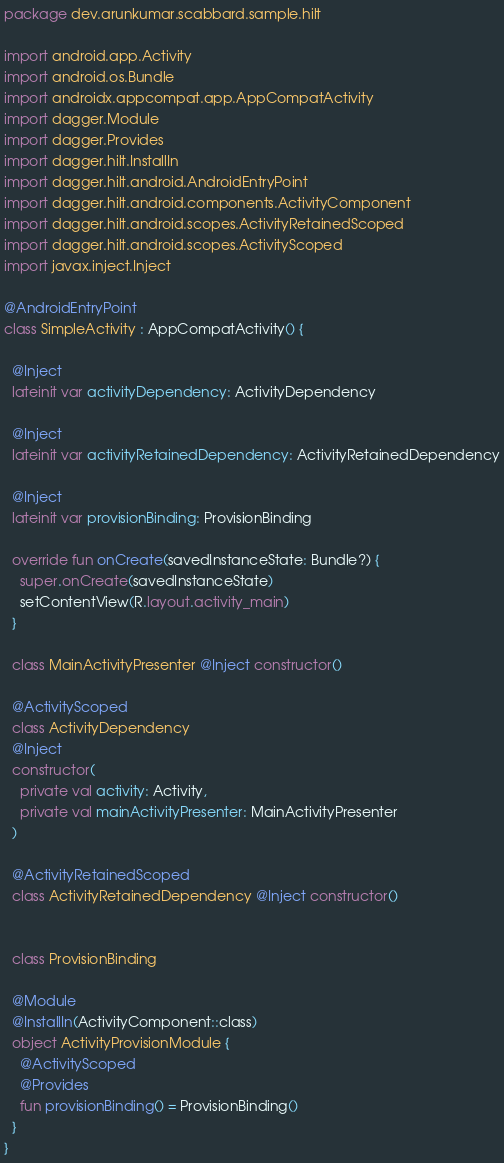Convert code to text. <code><loc_0><loc_0><loc_500><loc_500><_Kotlin_>package dev.arunkumar.scabbard.sample.hilt

import android.app.Activity
import android.os.Bundle
import androidx.appcompat.app.AppCompatActivity
import dagger.Module
import dagger.Provides
import dagger.hilt.InstallIn
import dagger.hilt.android.AndroidEntryPoint
import dagger.hilt.android.components.ActivityComponent
import dagger.hilt.android.scopes.ActivityRetainedScoped
import dagger.hilt.android.scopes.ActivityScoped
import javax.inject.Inject

@AndroidEntryPoint
class SimpleActivity : AppCompatActivity() {

  @Inject
  lateinit var activityDependency: ActivityDependency

  @Inject
  lateinit var activityRetainedDependency: ActivityRetainedDependency

  @Inject
  lateinit var provisionBinding: ProvisionBinding

  override fun onCreate(savedInstanceState: Bundle?) {
    super.onCreate(savedInstanceState)
    setContentView(R.layout.activity_main)
  }

  class MainActivityPresenter @Inject constructor()

  @ActivityScoped
  class ActivityDependency
  @Inject
  constructor(
    private val activity: Activity,
    private val mainActivityPresenter: MainActivityPresenter
  )

  @ActivityRetainedScoped
  class ActivityRetainedDependency @Inject constructor()


  class ProvisionBinding

  @Module
  @InstallIn(ActivityComponent::class)
  object ActivityProvisionModule {
    @ActivityScoped
    @Provides
    fun provisionBinding() = ProvisionBinding()
  }
}
</code> 